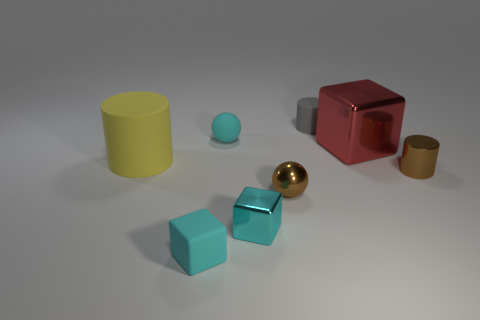Add 1 big cyan matte blocks. How many objects exist? 9 Subtract all cylinders. How many objects are left? 5 Add 3 small rubber cubes. How many small rubber cubes are left? 4 Add 3 gray things. How many gray things exist? 4 Subtract 0 purple cylinders. How many objects are left? 8 Subtract all tiny brown metallic things. Subtract all tiny green spheres. How many objects are left? 6 